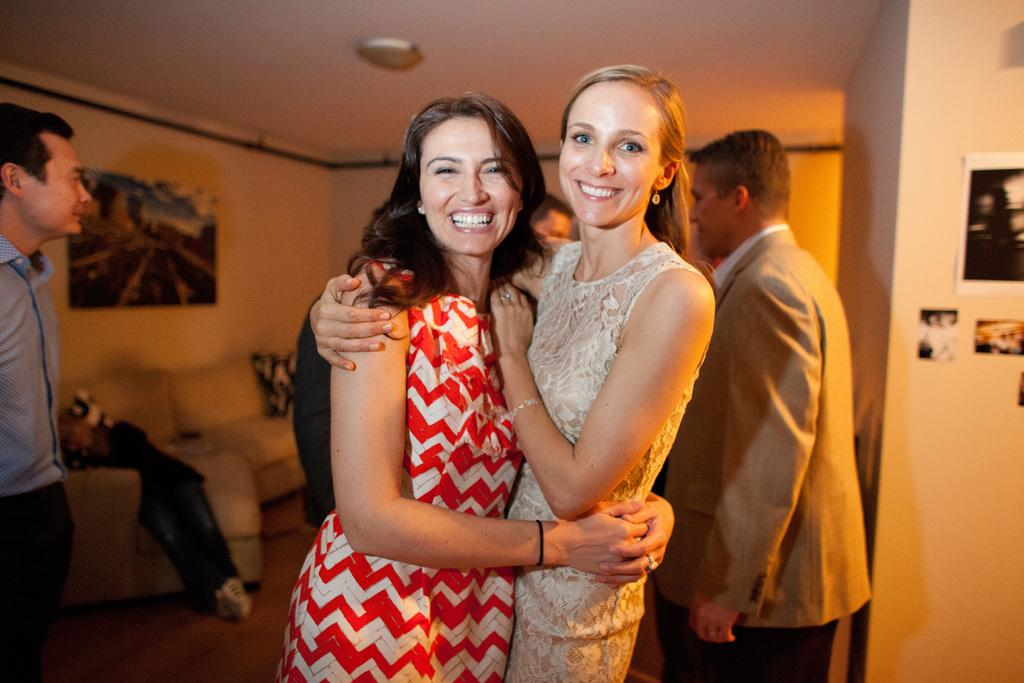How many women are present in the image? There are 2 women in the image. What are the women doing in the image? The women are standing in a room and smiling. Can you describe the room in the image? There are other people in the room, and there is a couch on the left side of the image. What can be seen on the walls in the image? There are photos attached to the walls in the image. How much dirt can be seen on the floor in the image? There is no dirt visible on the floor in the image. What happens when the women smash the couch in the image? The women do not smash the couch in the image; they are standing near it and smiling. 